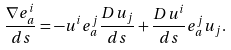<formula> <loc_0><loc_0><loc_500><loc_500>\frac { \nabla e ^ { i } _ { a } } { d s } = - u ^ { i } e ^ { j } _ { a } \frac { D u _ { j } } { d s } + \frac { D u ^ { i } } { d s } e ^ { j } _ { a } u _ { j } .</formula> 